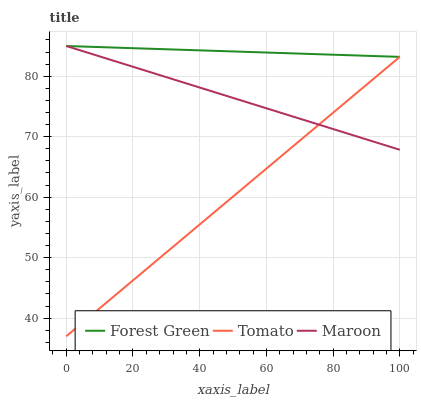Does Tomato have the minimum area under the curve?
Answer yes or no. Yes. Does Forest Green have the maximum area under the curve?
Answer yes or no. Yes. Does Maroon have the minimum area under the curve?
Answer yes or no. No. Does Maroon have the maximum area under the curve?
Answer yes or no. No. Is Forest Green the smoothest?
Answer yes or no. Yes. Is Maroon the roughest?
Answer yes or no. Yes. Is Maroon the smoothest?
Answer yes or no. No. Is Forest Green the roughest?
Answer yes or no. No. Does Tomato have the lowest value?
Answer yes or no. Yes. Does Maroon have the lowest value?
Answer yes or no. No. Does Maroon have the highest value?
Answer yes or no. Yes. Does Tomato intersect Forest Green?
Answer yes or no. Yes. Is Tomato less than Forest Green?
Answer yes or no. No. Is Tomato greater than Forest Green?
Answer yes or no. No. 